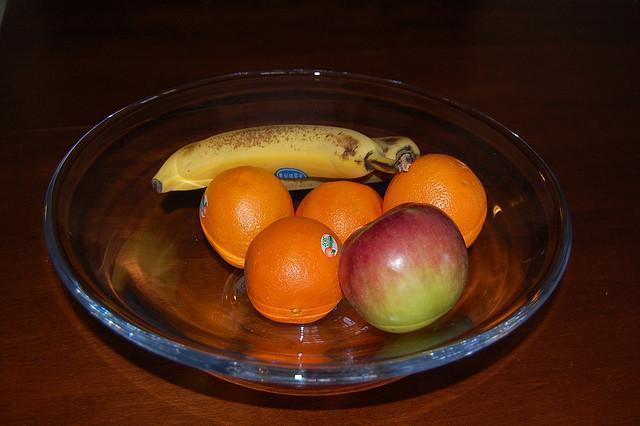What type of fruit is at the front of this fruit basket ahead of all of the oranges?
Choose the correct response and explain in the format: 'Answer: answer
Rationale: rationale.'
Options: Banana, apple, pineapple, pear. Answer: apple.
Rationale: It is identifiable by its round shape and red and green color.  it has a smooth shiny surface. 